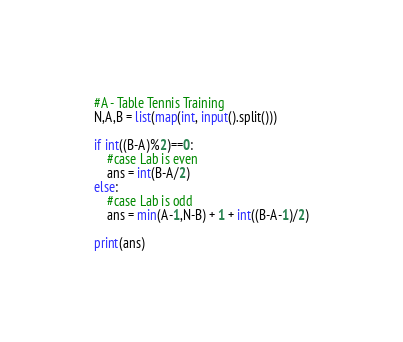<code> <loc_0><loc_0><loc_500><loc_500><_Python_>#A - Table Tennis Training
N,A,B = list(map(int, input().split()))

if int((B-A)%2)==0:
    #case Lab is even
    ans = int(B-A/2)
else:
    #case Lab is odd
    ans = min(A-1,N-B) + 1 + int((B-A-1)/2)

print(ans)</code> 